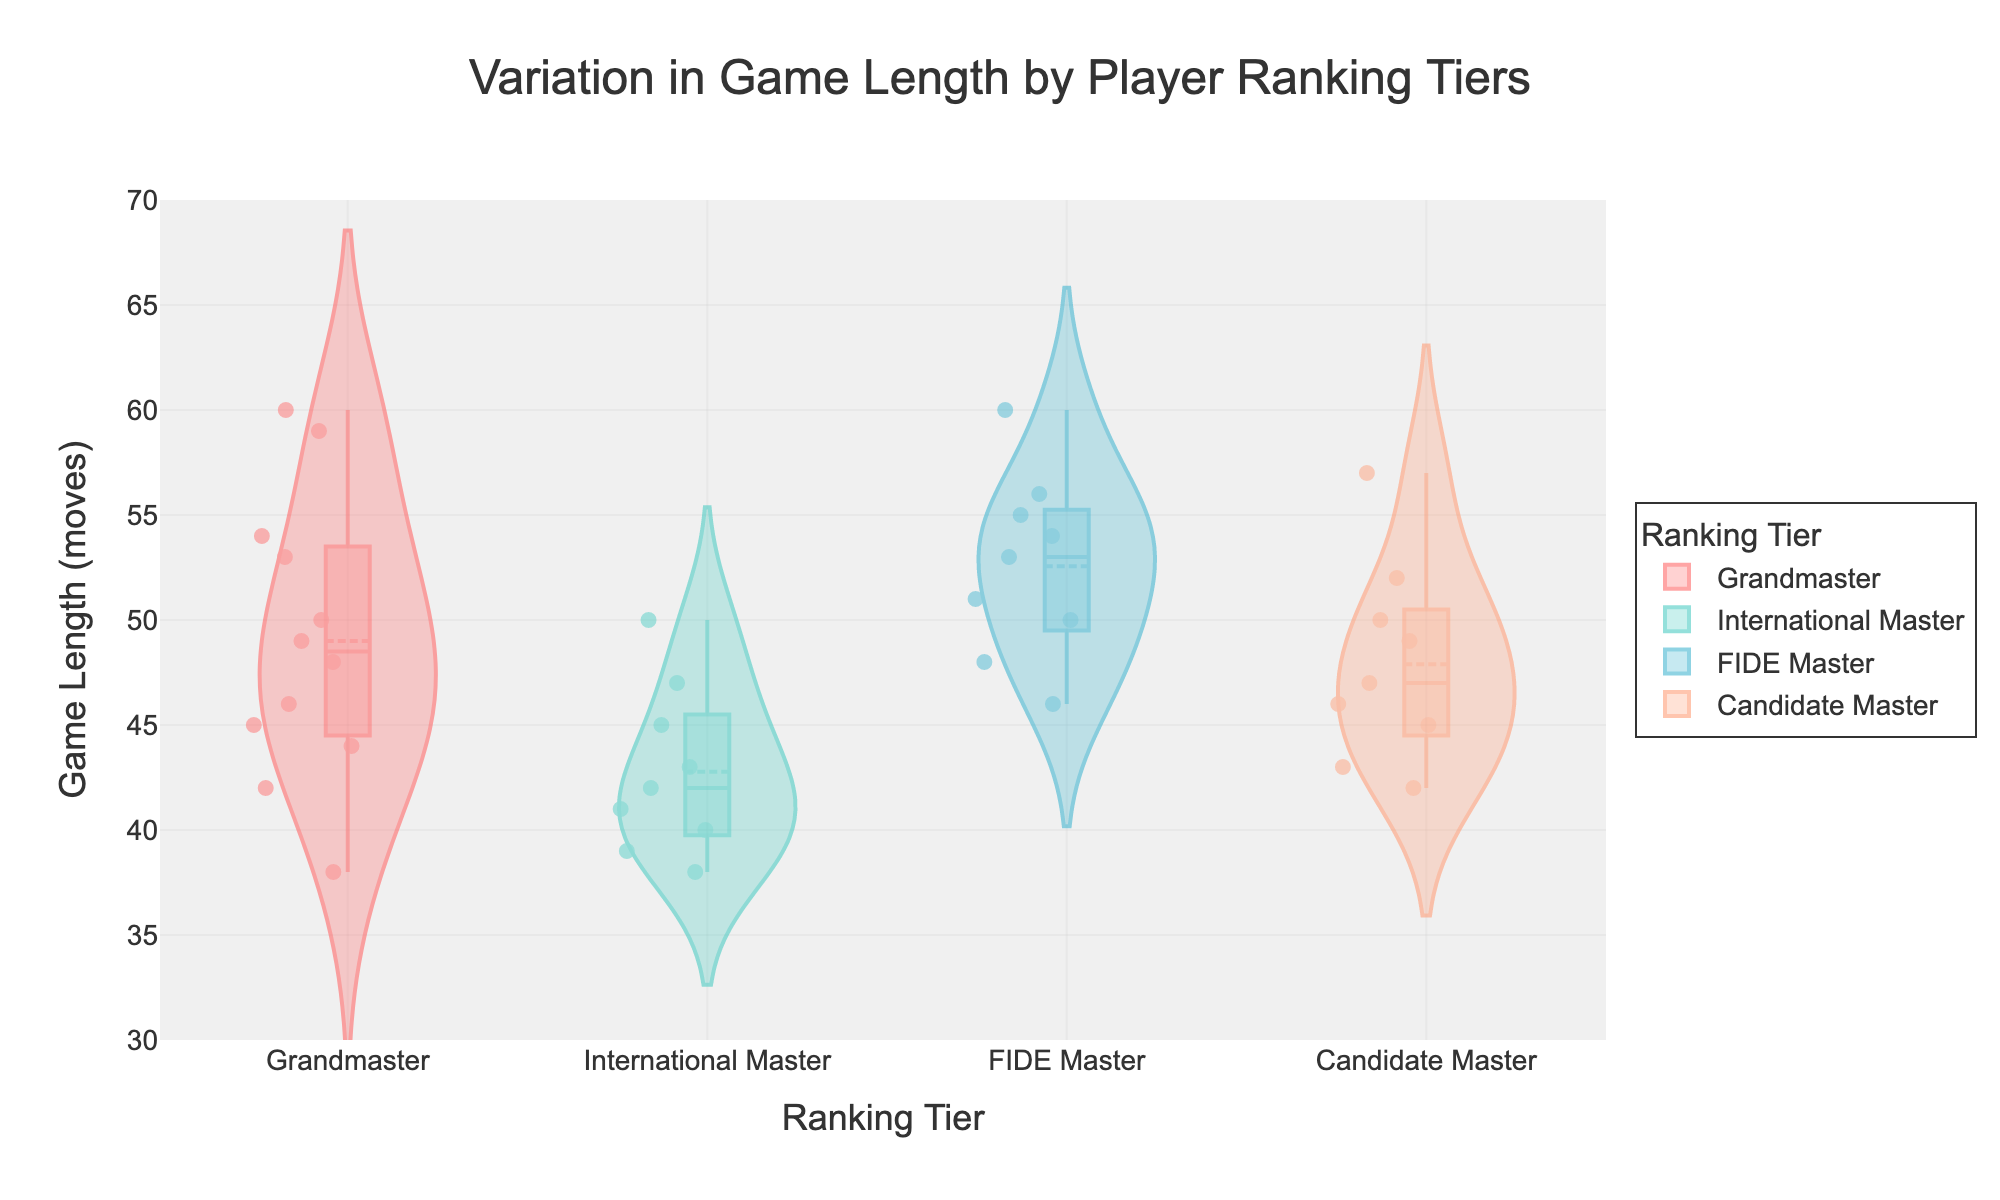1. What is the title of the chart? The title of the chart is displayed at the top, and it is written clearly in a larger font size than other text elements. It reads "Variation in Game Length by Player Ranking Tiers".
Answer: Variation in Game Length by Player Ranking Tiers 2. What are the four ranking tiers displayed on the x-axis? The x-axis of the chart has categorically separated sections, each labeled with a specific player ranking tier. The four ranking tiers are Grandmaster, International Master, FIDE Master, and Candidate Master.
Answer: Grandmaster, International Master, FIDE Master, Candidate Master 3. Which ranking tier has the highest median game length? The median game length for each ranking tier can be observed from the horizontal line within the box plot overlay on the violin charts. The FIDE Master tier has the highest median game length, as its median line is higher than the other tiers.
Answer: FIDE Master 4. What is the range of game lengths for Grandmasters? To find the range of game lengths, observe the violin plot for the Grandmaster tier, noting the lowest and highest data points. The game lengths range from approximately 38 to 60 moves.
Answer: Approximately 38 to 60 moves 5. How does the interquartile range (IQR) of the Candidate Master tier compare to that of the International Master tier? The interquartile range (IQR) is the range between the first and third quartiles, visible as the width of the box in the box plot overlay. The IQR for the Candidate Master tier is wider than that of the International Master tier, indicating more variability in game lengths.
Answer: The IQR for Candidate Masters is wider 6. Which ranking tier shows the most spread-out distribution of game lengths? The spread of game lengths is evident from the width of the violin plot. The Candidate Master tier shows the most spread-out distribution, as its violin plot is the widest, indicating a larger variance in game lengths.
Answer: Candidate Master 7. Compare the mean game lengths between Grandmasters and FIDE Masters. The mean game length is represented by the dashed line within the violin plots. The mean game length for FIDE Masters is higher than that of Grandmasters, as the dashed line in the FIDE Masters plot is higher.
Answer: FIDE Masters have a higher mean game length 8. What can be inferred from the box plot overlay on the violin charts? The box plot overlay helps in identifying key statistical values such as median, quartiles, and potential outliers. By observing these overlays, we can infer the central tendency, dispersion, and skewness of game lengths across different ranking tiers.
Answer: Central tendency, dispersion, and skewness 9. Are there any overlapping data points within the International Master tier? Data points within each tier are displayed as individual points overlaid on the violin plot. There are some overlapping data points in the International Master tier, which can be identified by closely grouped points.
Answer: Yes 